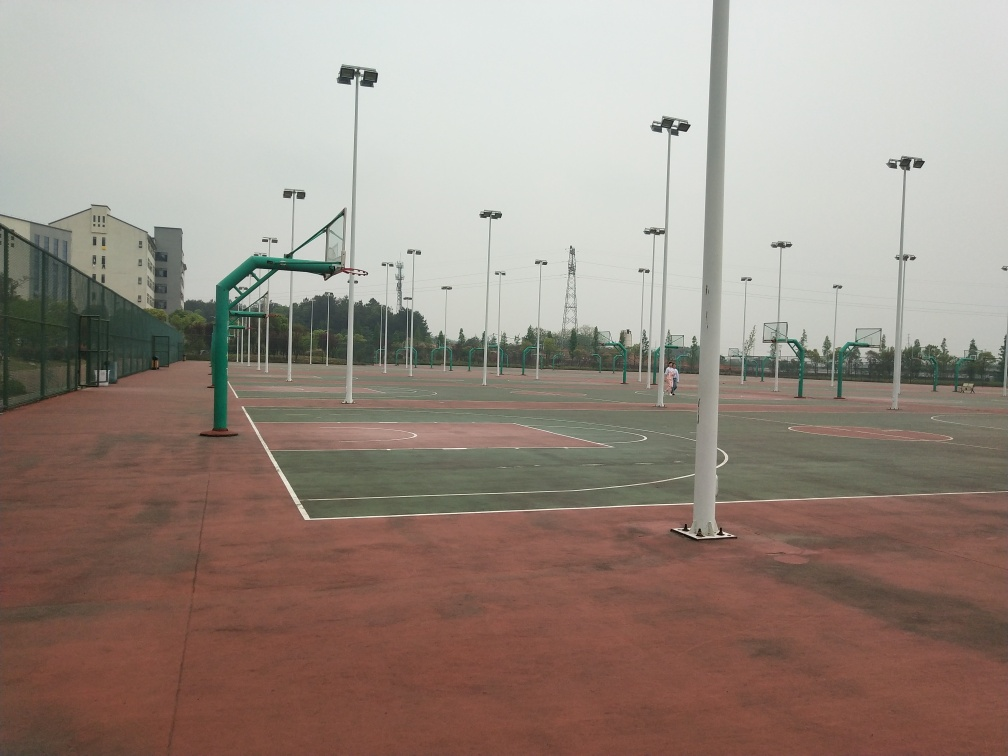What is the composition of this image? The image depicts an outdoor sports facility with multiple basketball courts. The surface appears to be made of red and green rubberized material, which is commonly used for athletic courts to provide a durable, non-slip surface. Several basketball hoops are installed at varying heights, suggesting the area accommodates different age groups or skill levels. The courts are surrounded by chain-link fencing, and lighting poles are installed to illuminate the area for night play. In the background, there are buildings that could be part of a school or community center, hinting that the facility might be intended for public or institutional use. 